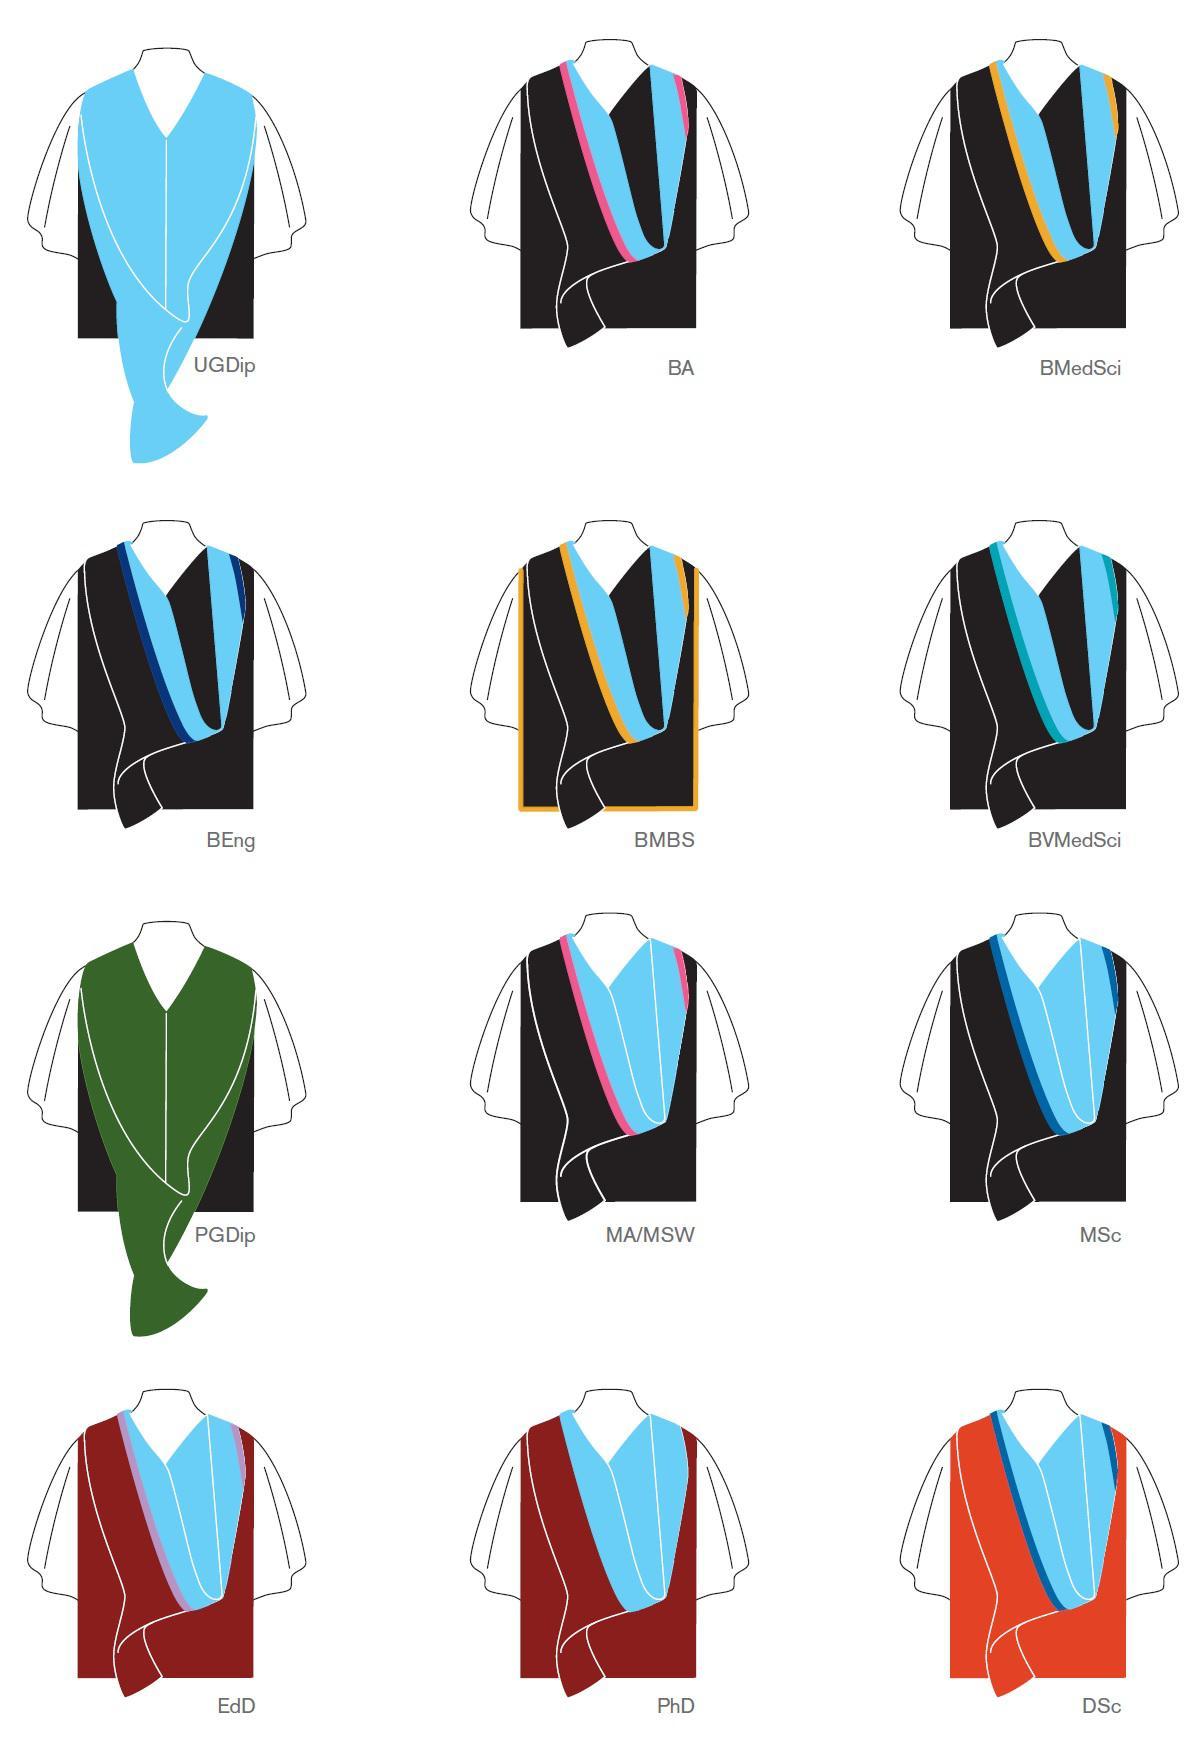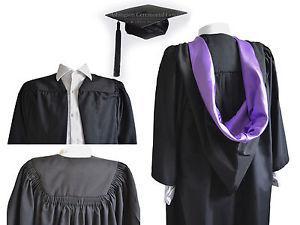The first image is the image on the left, the second image is the image on the right. Assess this claim about the two images: "There is a women in one of the images.". Correct or not? Answer yes or no. No. 